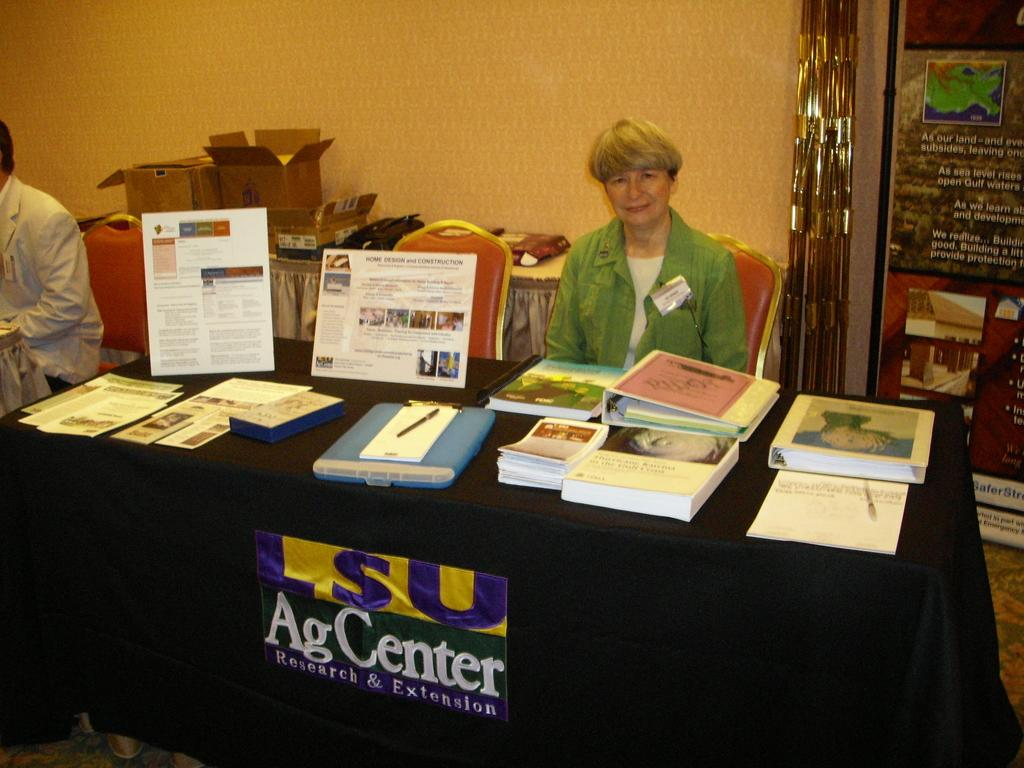<image>
Present a compact description of the photo's key features. A woman in a green shirt sits at a table for the Ag Center at LSU. 